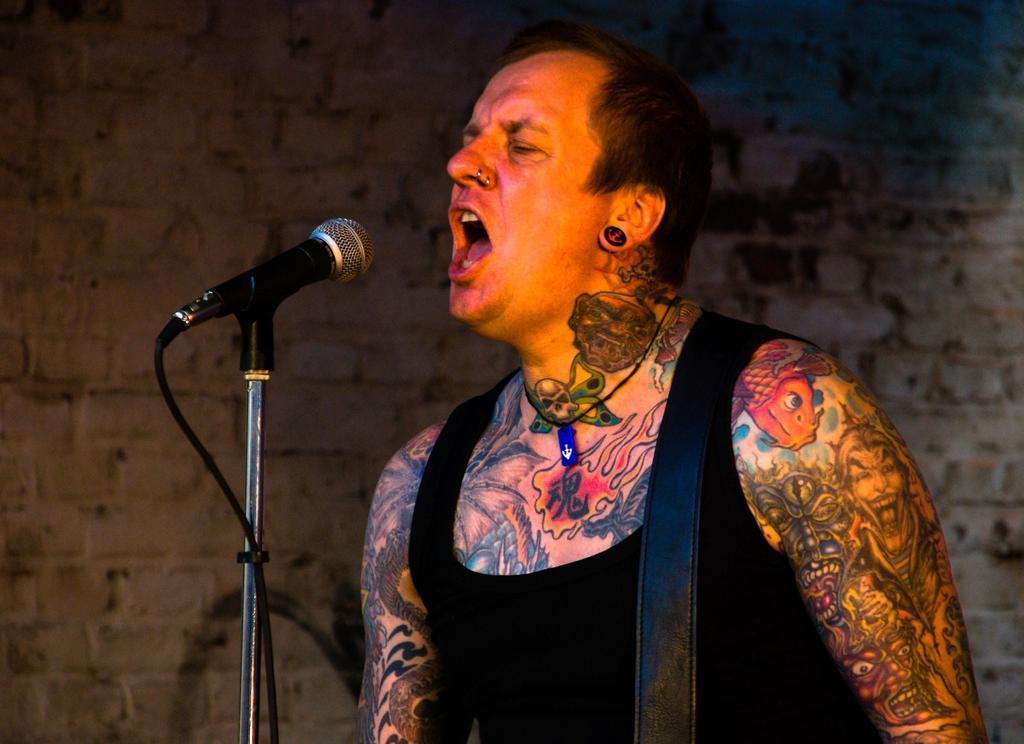What is the person in the image doing? The person is singing in the image. What is the person using while singing? The person is in front of a microphone. Can you describe any unique features of the person's appearance? The person has tattoos on their body. What colors are used for the background wall in the image? The background wall is in white and black colors. What type of slope can be seen in the image? There is no slope present in the image. What need does the person have while singing in the image? The person does not appear to have any specific need while singing in the image. 